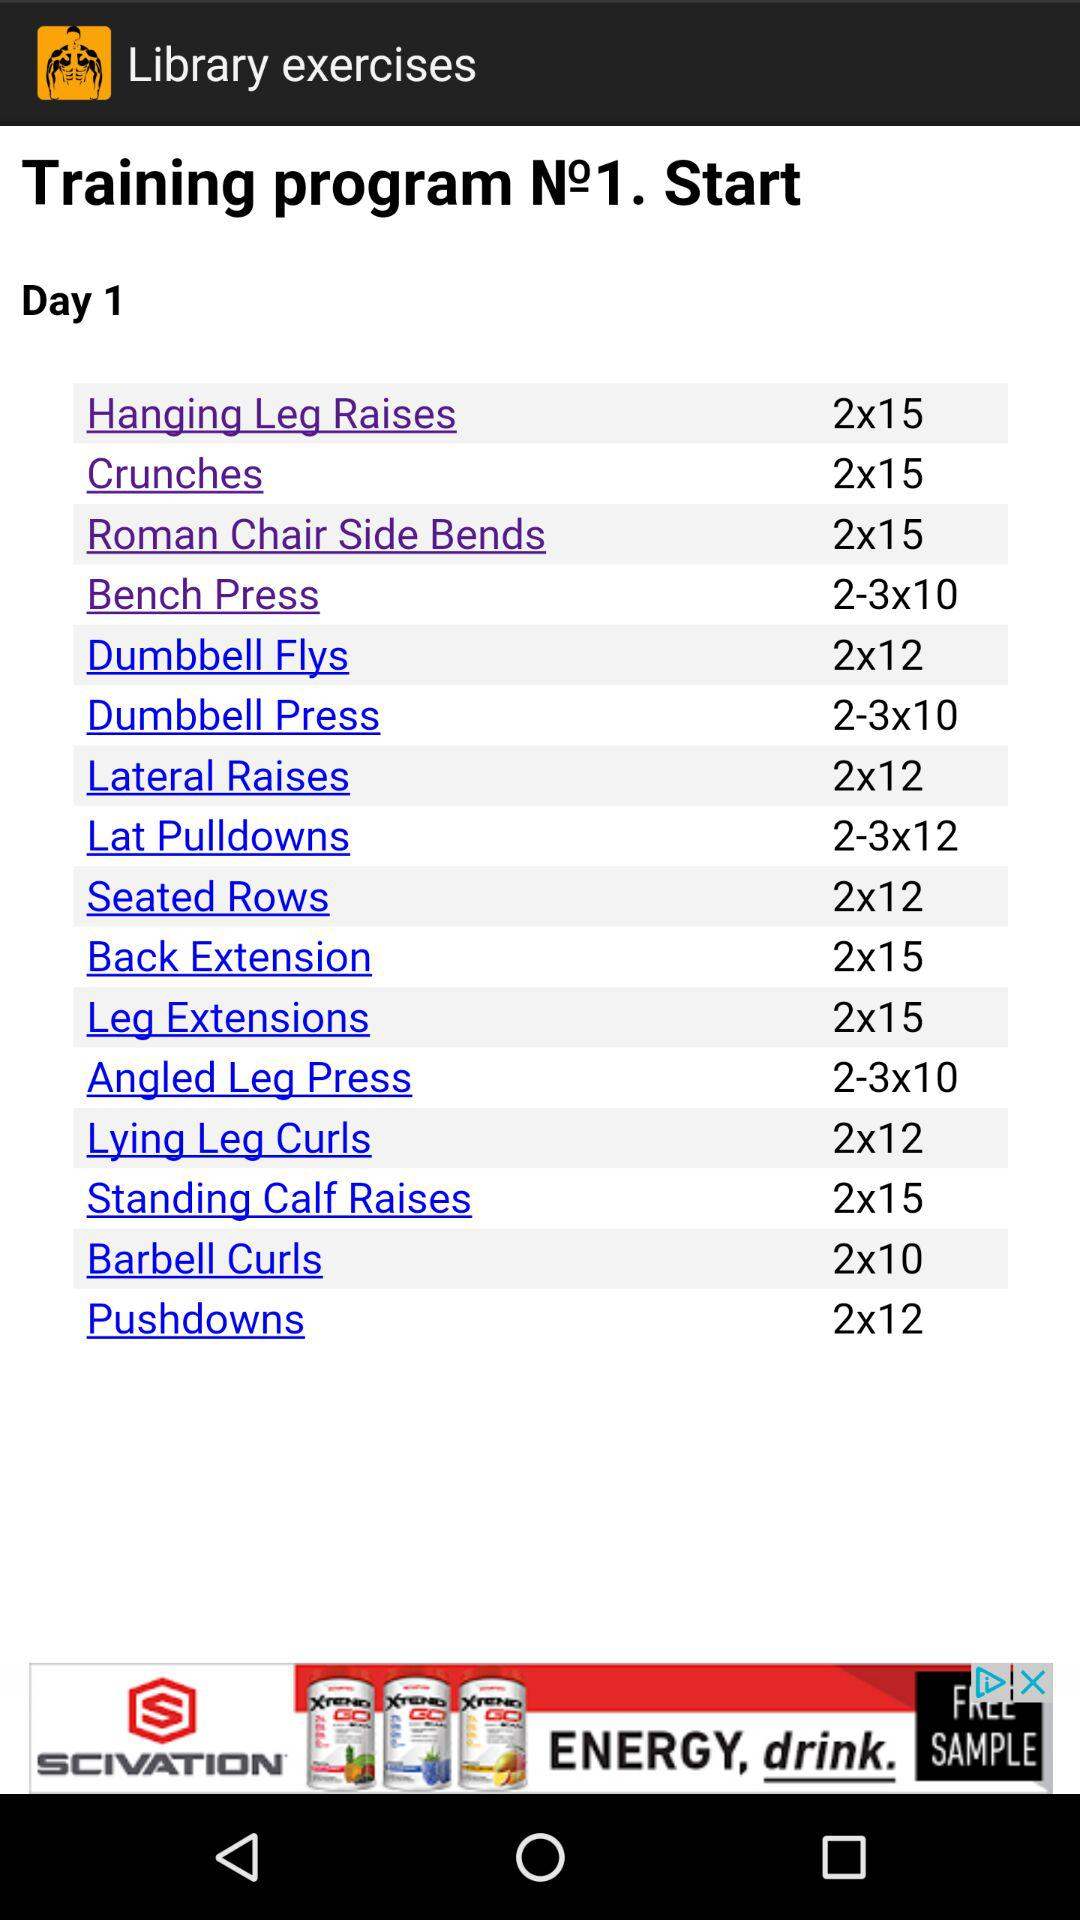What is the number of repetitions for crunches? The number of repetitions for crunches is 15. 